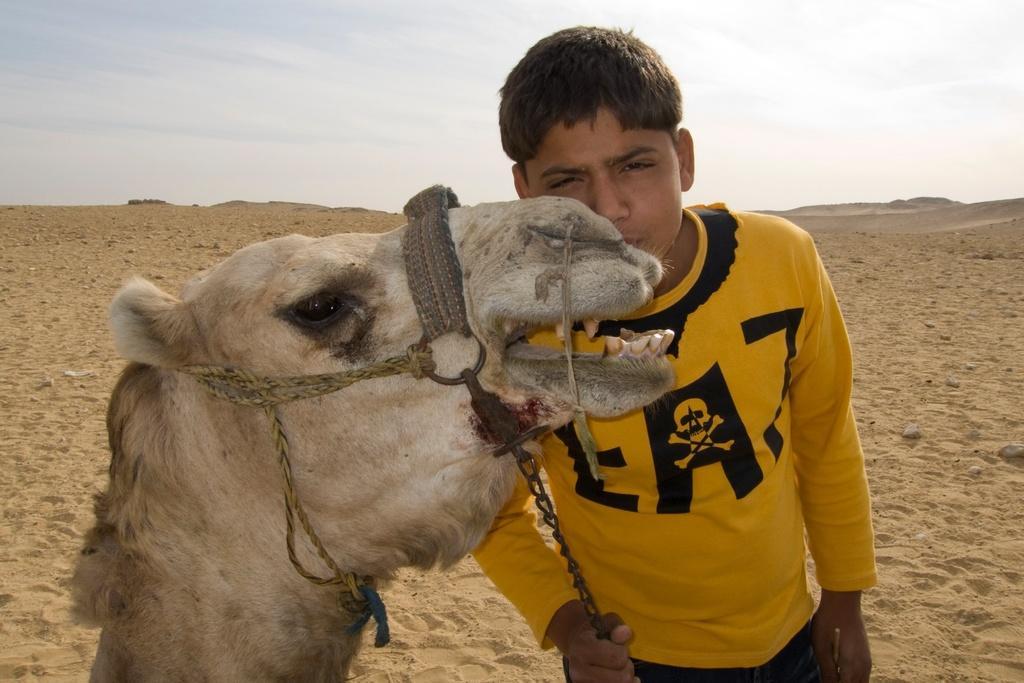Describe this image in one or two sentences. In this picture we can see a person in the yellow t shirt is holding a chain. In front of the person there is a camel. Behind the person there is sand and the sky. 